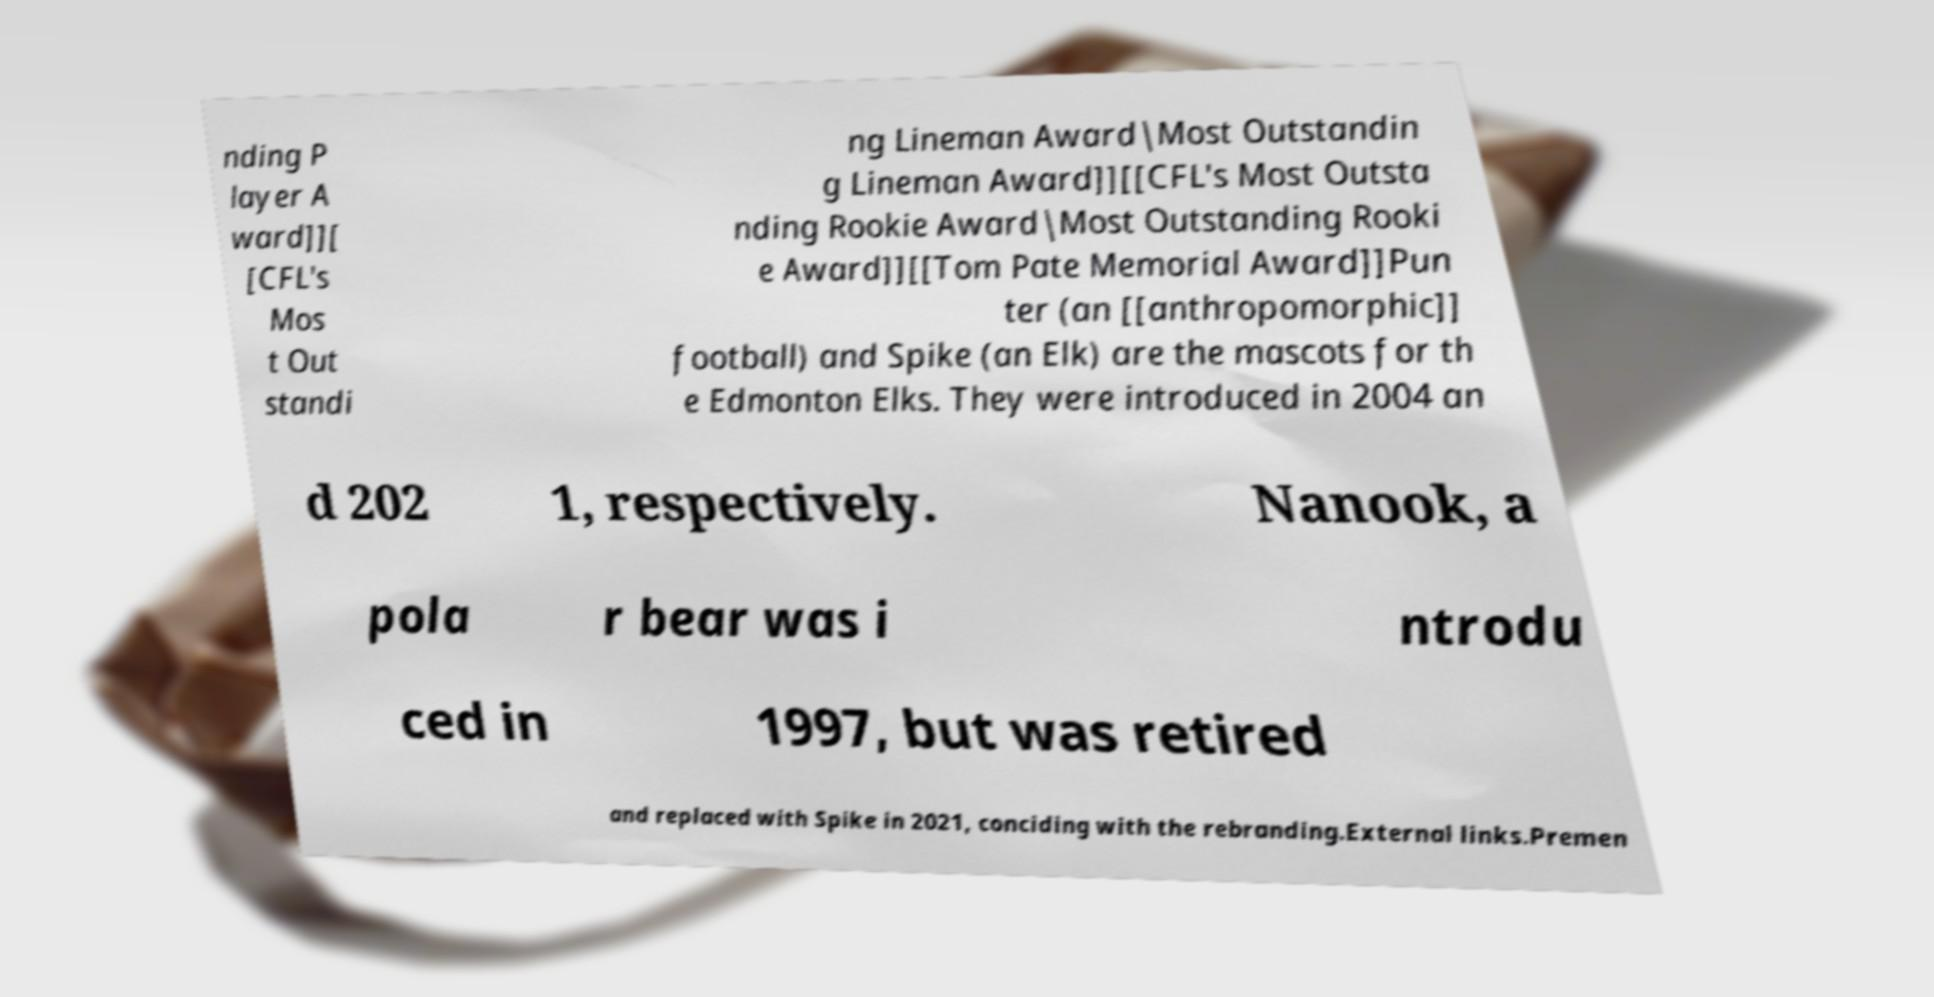Can you read and provide the text displayed in the image?This photo seems to have some interesting text. Can you extract and type it out for me? nding P layer A ward]][ [CFL's Mos t Out standi ng Lineman Award|Most Outstandin g Lineman Award]][[CFL's Most Outsta nding Rookie Award|Most Outstanding Rooki e Award]][[Tom Pate Memorial Award]]Pun ter (an [[anthropomorphic]] football) and Spike (an Elk) are the mascots for th e Edmonton Elks. They were introduced in 2004 an d 202 1, respectively. Nanook, a pola r bear was i ntrodu ced in 1997, but was retired and replaced with Spike in 2021, conciding with the rebranding.External links.Premen 